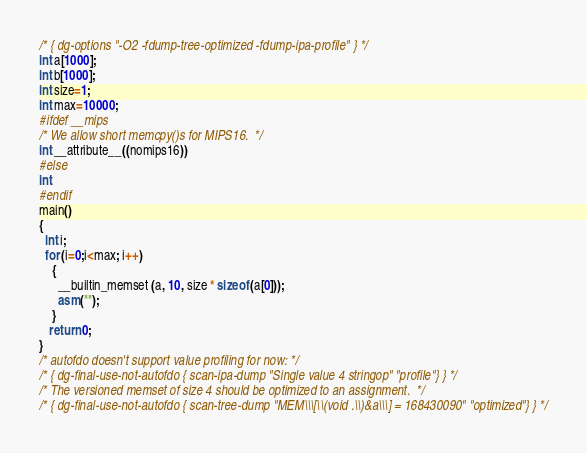Convert code to text. <code><loc_0><loc_0><loc_500><loc_500><_C_>/* { dg-options "-O2 -fdump-tree-optimized -fdump-ipa-profile" } */
int a[1000];
int b[1000];
int size=1;
int max=10000;
#ifdef __mips
/* We allow short memcpy()s for MIPS16.  */
int __attribute__((nomips16))
#else
int
#endif
main()
{
  int i;
  for (i=0;i<max; i++)
    {
      __builtin_memset (a, 10, size * sizeof (a[0]));
      asm("");
    }
   return 0;
}
/* autofdo doesn't support value profiling for now: */
/* { dg-final-use-not-autofdo { scan-ipa-dump "Single value 4 stringop" "profile"} } */
/* The versioned memset of size 4 should be optimized to an assignment.  */
/* { dg-final-use-not-autofdo { scan-tree-dump "MEM\\\[\\(void .\\)&a\\\] = 168430090" "optimized"} } */
</code> 